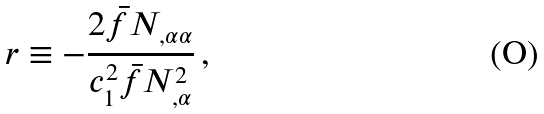<formula> <loc_0><loc_0><loc_500><loc_500>r \equiv - \frac { 2 \bar { f } { N } _ { , \alpha \alpha } } { c _ { 1 } ^ { 2 } \bar { f } { N } _ { , \alpha } ^ { 2 } } \, ,</formula> 